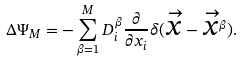<formula> <loc_0><loc_0><loc_500><loc_500>\Delta \Psi _ { M } = - \sum _ { \beta = 1 } ^ { M } D _ { i } ^ { \beta } \frac { \partial } { \partial x _ { i } } \delta ( \overrightarrow { x } - \overrightarrow { x } ^ { \beta } ) .</formula> 